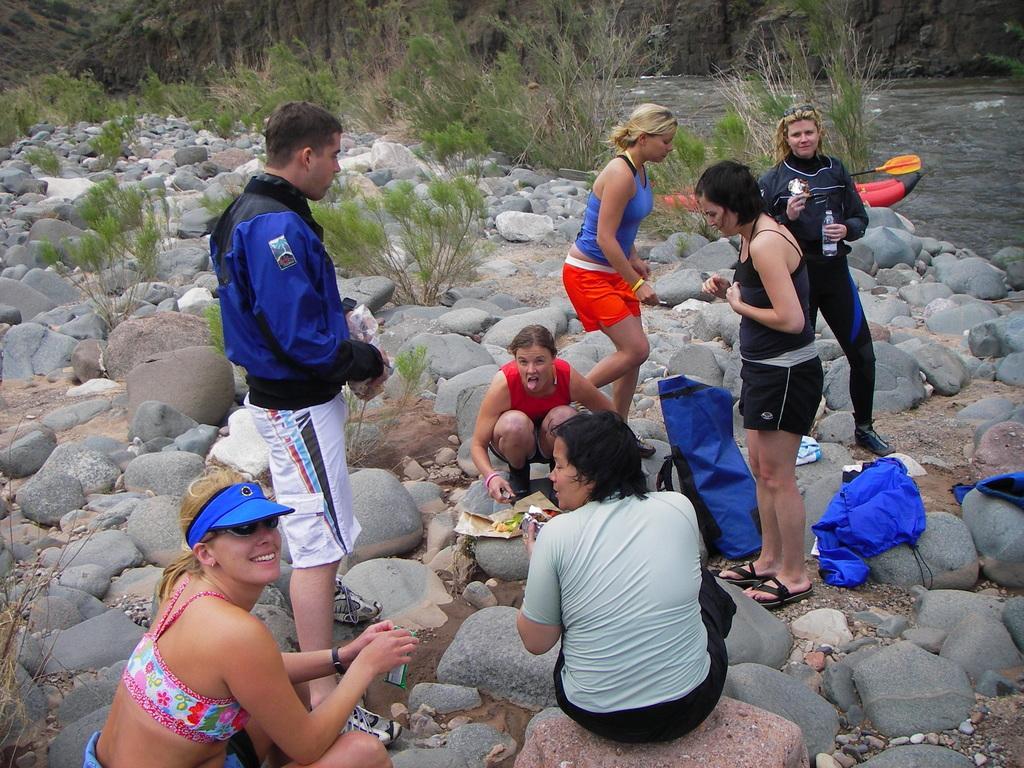How would you summarize this image in a sentence or two? In the center of the image there are people on the stones. In the background of the image there is grass and water. 